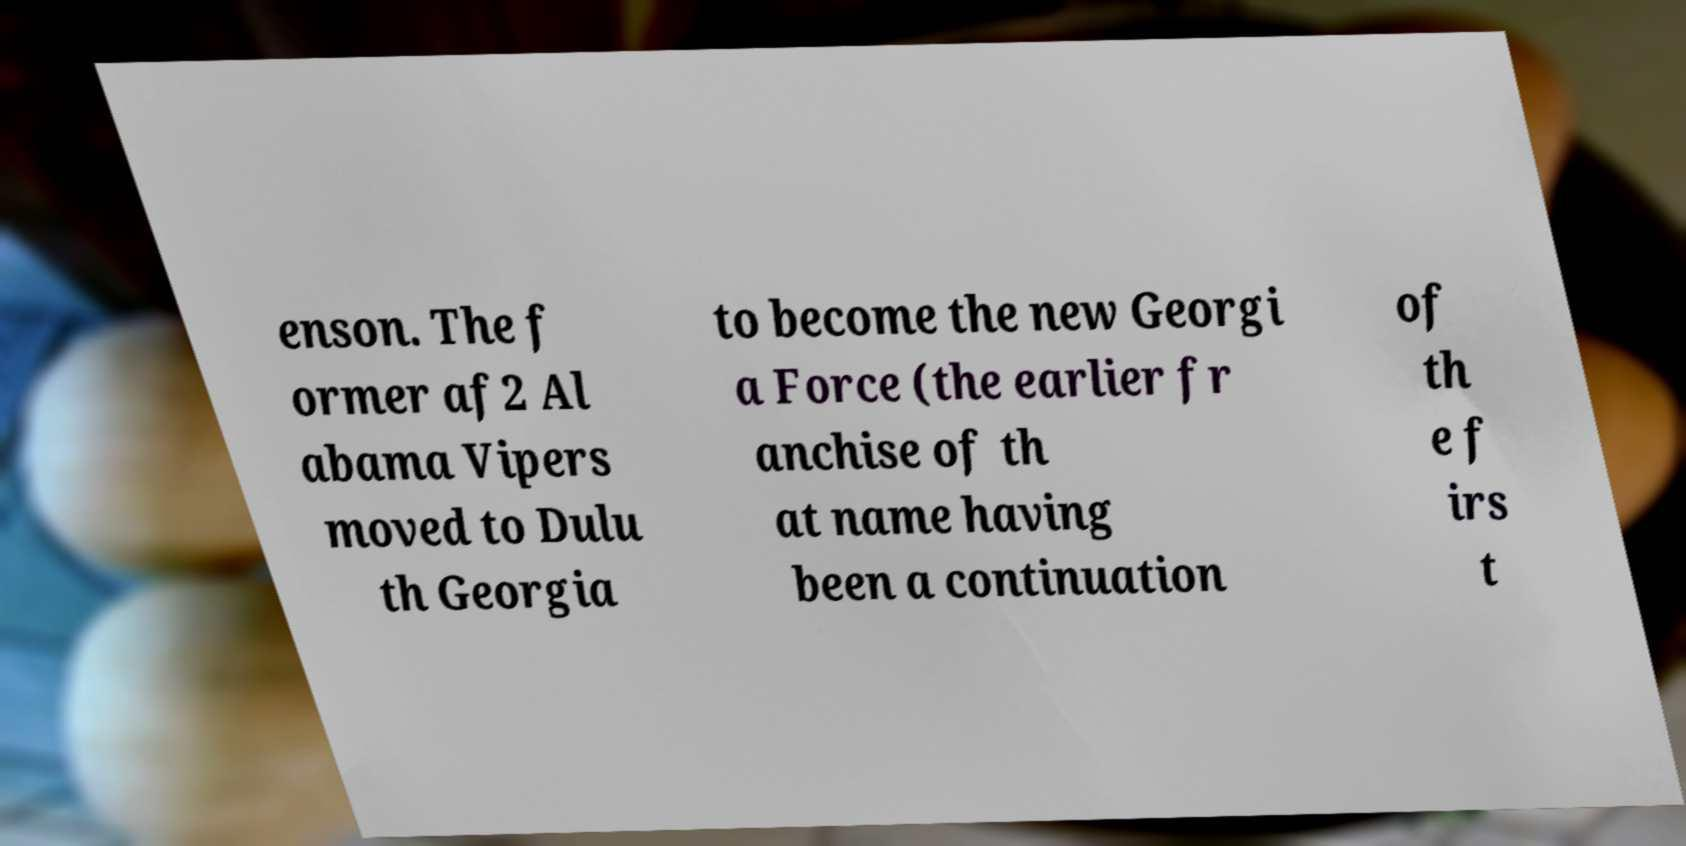I need the written content from this picture converted into text. Can you do that? enson. The f ormer af2 Al abama Vipers moved to Dulu th Georgia to become the new Georgi a Force (the earlier fr anchise of th at name having been a continuation of th e f irs t 